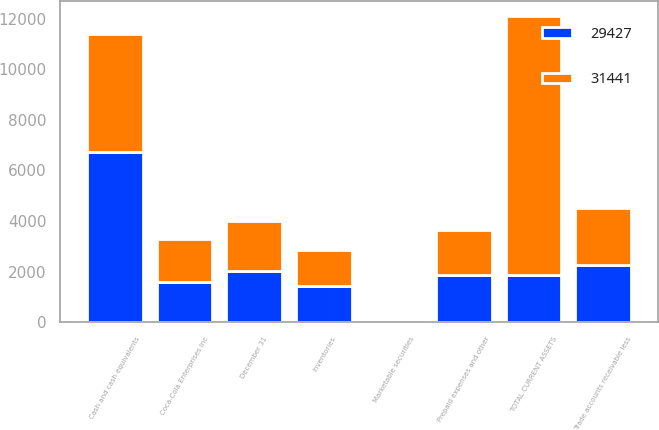Convert chart to OTSL. <chart><loc_0><loc_0><loc_500><loc_500><stacked_bar_chart><ecel><fcel>December 31<fcel>Cash and cash equivalents<fcel>Marketable securities<fcel>Trade accounts receivable less<fcel>Inventories<fcel>Prepaid expenses and other<fcel>TOTAL CURRENT ASSETS<fcel>Coca-Cola Enterprises Inc<nl><fcel>31441<fcel>2005<fcel>4701<fcel>66<fcel>2281<fcel>1424<fcel>1778<fcel>10250<fcel>1731<nl><fcel>29427<fcel>2004<fcel>6707<fcel>61<fcel>2244<fcel>1420<fcel>1849<fcel>1849<fcel>1569<nl></chart> 